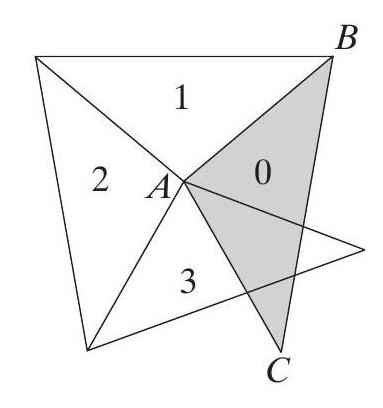We are going to make a spiral of isosceles triangles. We'll start with the shaded triangle $B A C$, which has a top angle $\angle B A C=100^{\circ}$, and move counterclockwise. Let $\triangle A B C$ have number 0. Every of the next triangles (with numbers 1, 2, $3, \ldots$ ) will have exactly one edge adjoining the previous one (see the picture). What will be the number of the first triangle which precisely covers triangle $\mathrm{nr}$. 0? The first triangle to exactly cover triangle number 0, the shaded triangle $B A C$, is triangle number 18. This result is derived by understanding the geometric progression and rotation of isosceles triangles as they expand in a counterclockwise direction. Each subsequent triangle shares an edge with its predecessor and rotates slightly from the last, maintaining the triangle spiral structure until they perfectly overlap with the starting triangle. 